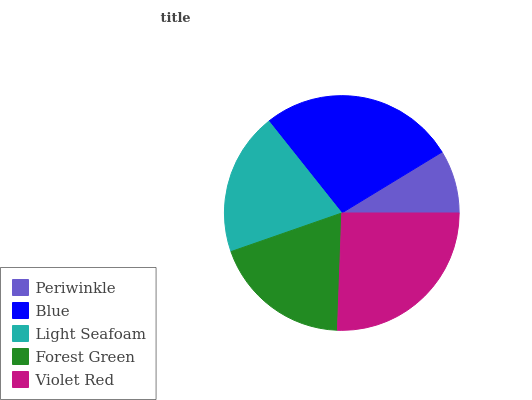Is Periwinkle the minimum?
Answer yes or no. Yes. Is Blue the maximum?
Answer yes or no. Yes. Is Light Seafoam the minimum?
Answer yes or no. No. Is Light Seafoam the maximum?
Answer yes or no. No. Is Blue greater than Light Seafoam?
Answer yes or no. Yes. Is Light Seafoam less than Blue?
Answer yes or no. Yes. Is Light Seafoam greater than Blue?
Answer yes or no. No. Is Blue less than Light Seafoam?
Answer yes or no. No. Is Light Seafoam the high median?
Answer yes or no. Yes. Is Light Seafoam the low median?
Answer yes or no. Yes. Is Violet Red the high median?
Answer yes or no. No. Is Violet Red the low median?
Answer yes or no. No. 